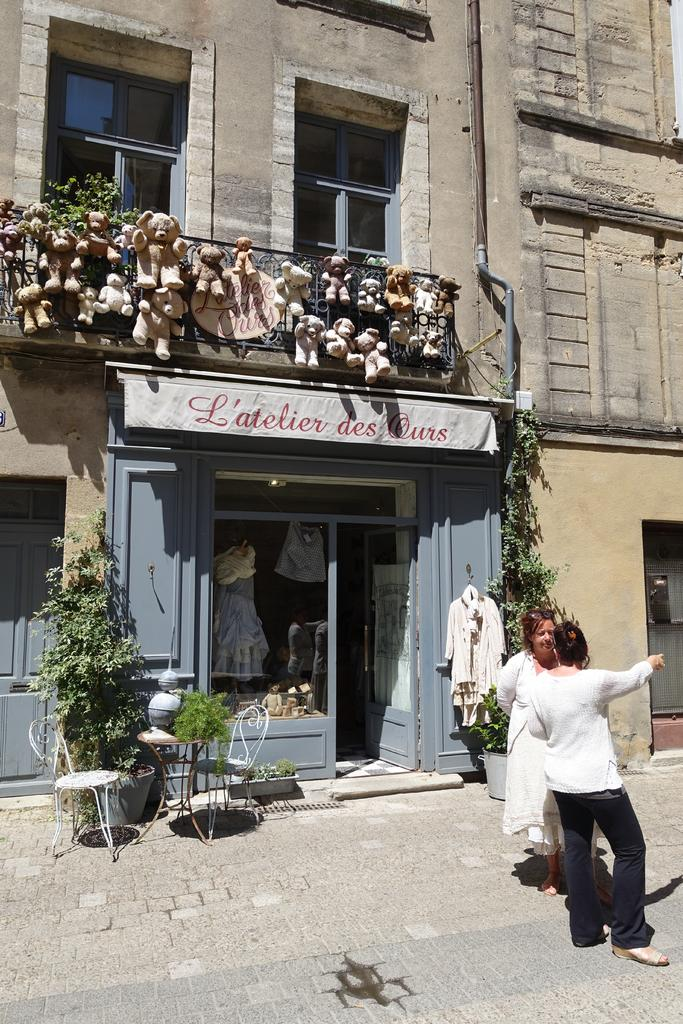How many people are in the image? There are two women in the image. What are the women doing in the image? The women are talking to each other. What can be seen in the background of the image? There are plants, chairs, toys, and a building in the background of the image. What type of bird can be seen taking a bath in the image? There is no bird or bath present in the image. How much salt is visible on the chairs in the background? There is no salt present in the image. 